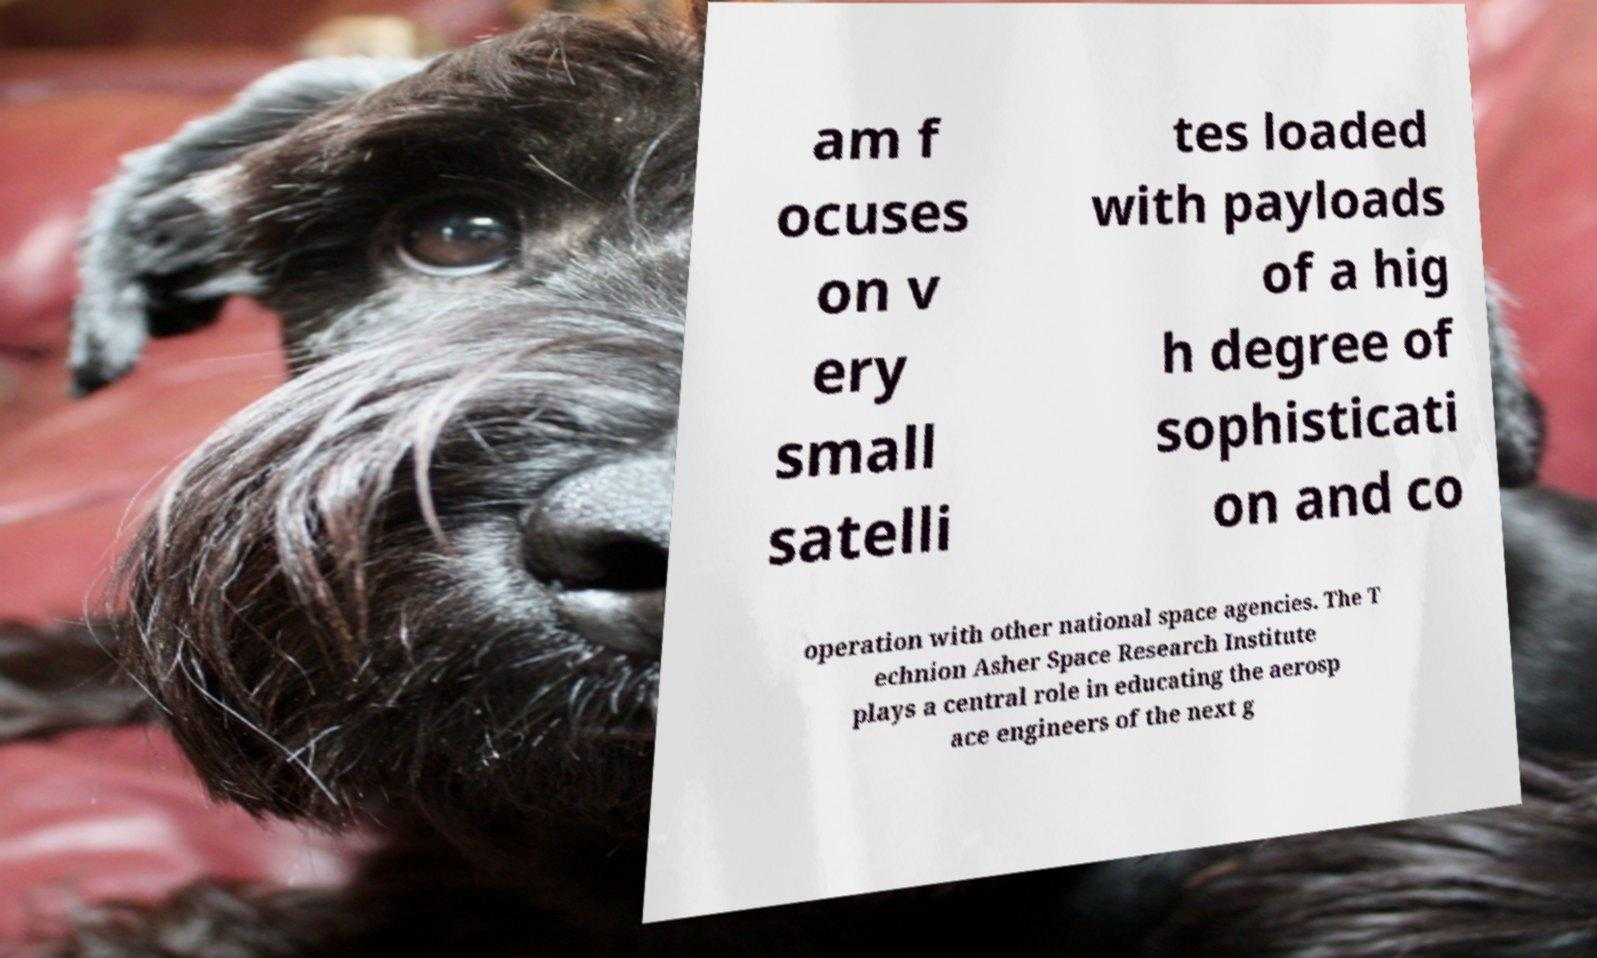Can you read and provide the text displayed in the image?This photo seems to have some interesting text. Can you extract and type it out for me? am f ocuses on v ery small satelli tes loaded with payloads of a hig h degree of sophisticati on and co operation with other national space agencies. The T echnion Asher Space Research Institute plays a central role in educating the aerosp ace engineers of the next g 